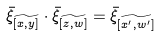<formula> <loc_0><loc_0><loc_500><loc_500>\bar { \xi } _ { \widetilde { [ x , y ] } } \cdot \bar { \xi } _ { \widetilde { [ z , w ] } } = \bar { \xi } _ { \widetilde { [ x ^ { \prime } , w ^ { \prime } ] } }</formula> 